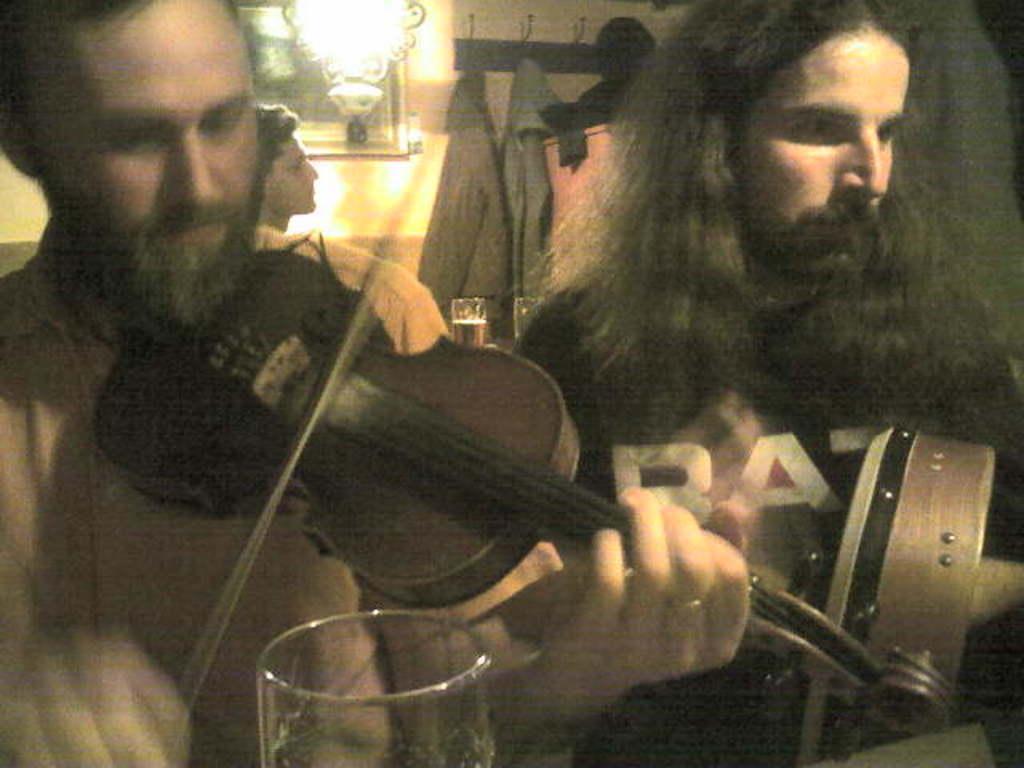In one or two sentences, can you explain what this image depicts? In this image there are three person. On the left side the person is playing a violin. At the background the frame is attached to the wall,we can see a glass. 